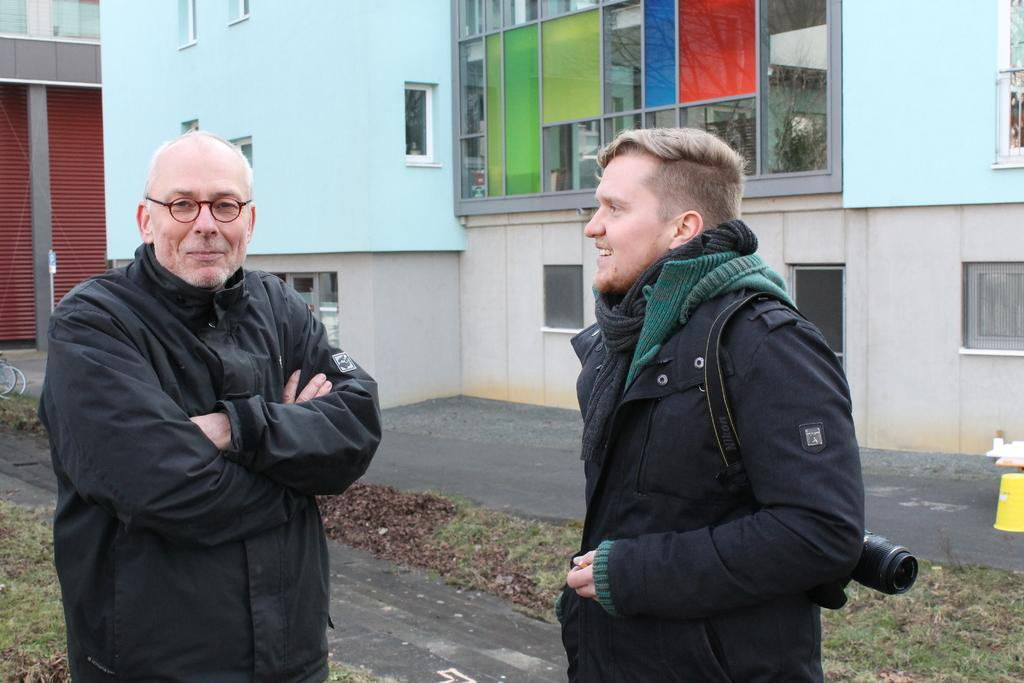How many people are in the image? There are two men standing in the image. What are the expressions on their faces? The men are smiling in the image. Can you describe the attire of one of the men? One of the men is wearing a camera. What can be seen in the background of the image? There are buildings, a wall, and glass windows in the background of the image. How does the bottle react during the earthquake in the image? There is no bottle or earthquake present in the image. What type of tin is being used by the men in the image? There is no tin visible in the image; the men are not using any tools or objects besides the camera. 